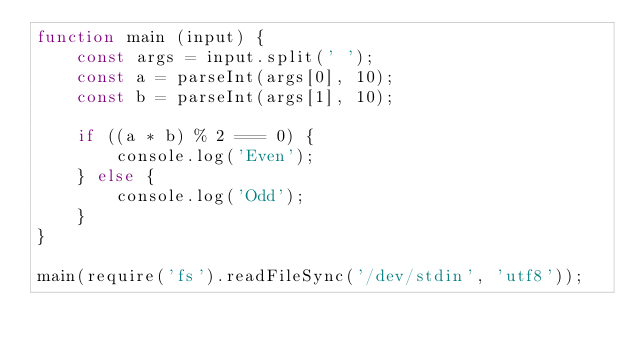Convert code to text. <code><loc_0><loc_0><loc_500><loc_500><_JavaScript_>function main (input) {
    const args = input.split(' ');
    const a = parseInt(args[0], 10);
    const b = parseInt(args[1], 10);

    if ((a * b) % 2 === 0) {
        console.log('Even');
    } else {
        console.log('Odd');
    }
}

main(require('fs').readFileSync('/dev/stdin', 'utf8'));</code> 